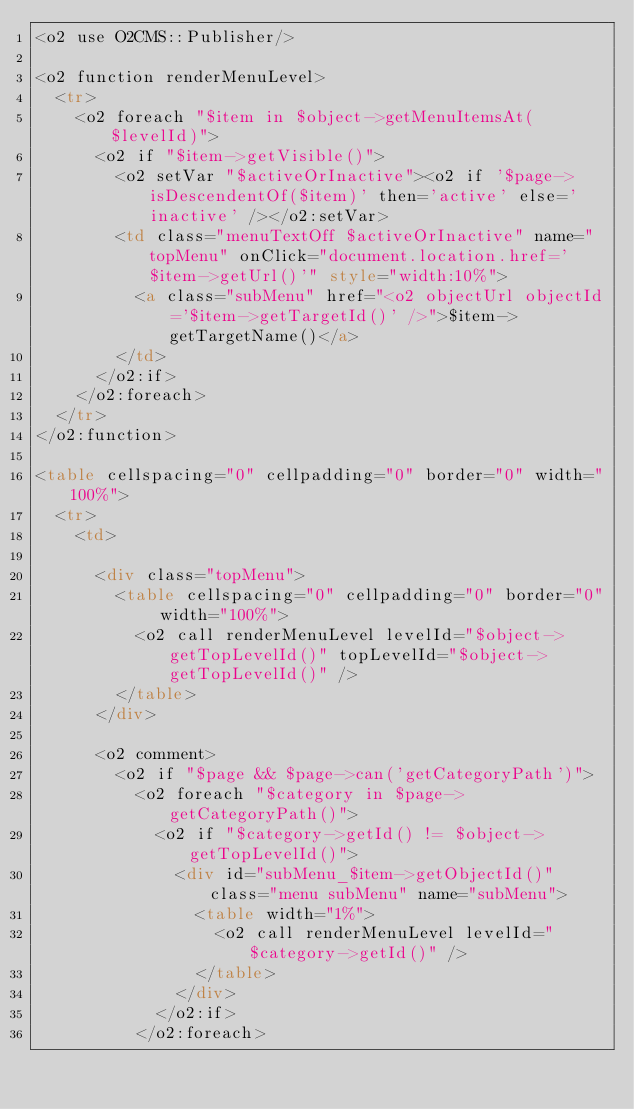<code> <loc_0><loc_0><loc_500><loc_500><_HTML_><o2 use O2CMS::Publisher/>

<o2 function renderMenuLevel>
  <tr>
    <o2 foreach "$item in $object->getMenuItemsAt($levelId)">
      <o2 if "$item->getVisible()">
        <o2 setVar "$activeOrInactive"><o2 if '$page->isDescendentOf($item)' then='active' else='inactive' /></o2:setVar>
        <td class="menuTextOff $activeOrInactive" name="topMenu" onClick="document.location.href='$item->getUrl()'" style="width:10%">
          <a class="subMenu" href="<o2 objectUrl objectId='$item->getTargetId()' />">$item->getTargetName()</a>
        </td>
      </o2:if>
    </o2:foreach>
  </tr>
</o2:function>

<table cellspacing="0" cellpadding="0" border="0" width="100%">
  <tr>
    <td>

      <div class="topMenu">
        <table cellspacing="0" cellpadding="0" border="0" width="100%">
          <o2 call renderMenuLevel levelId="$object->getTopLevelId()" topLevelId="$object->getTopLevelId()" />
        </table>
      </div>

      <o2 comment>
        <o2 if "$page && $page->can('getCategoryPath')">
          <o2 foreach "$category in $page->getCategoryPath()">
            <o2 if "$category->getId() != $object->getTopLevelId()">
              <div id="subMenu_$item->getObjectId()" class="menu subMenu" name="subMenu">
                <table width="1%">
                  <o2 call renderMenuLevel levelId="$category->getId()" />
                </table>
              </div>
            </o2:if>
          </o2:foreach></code> 